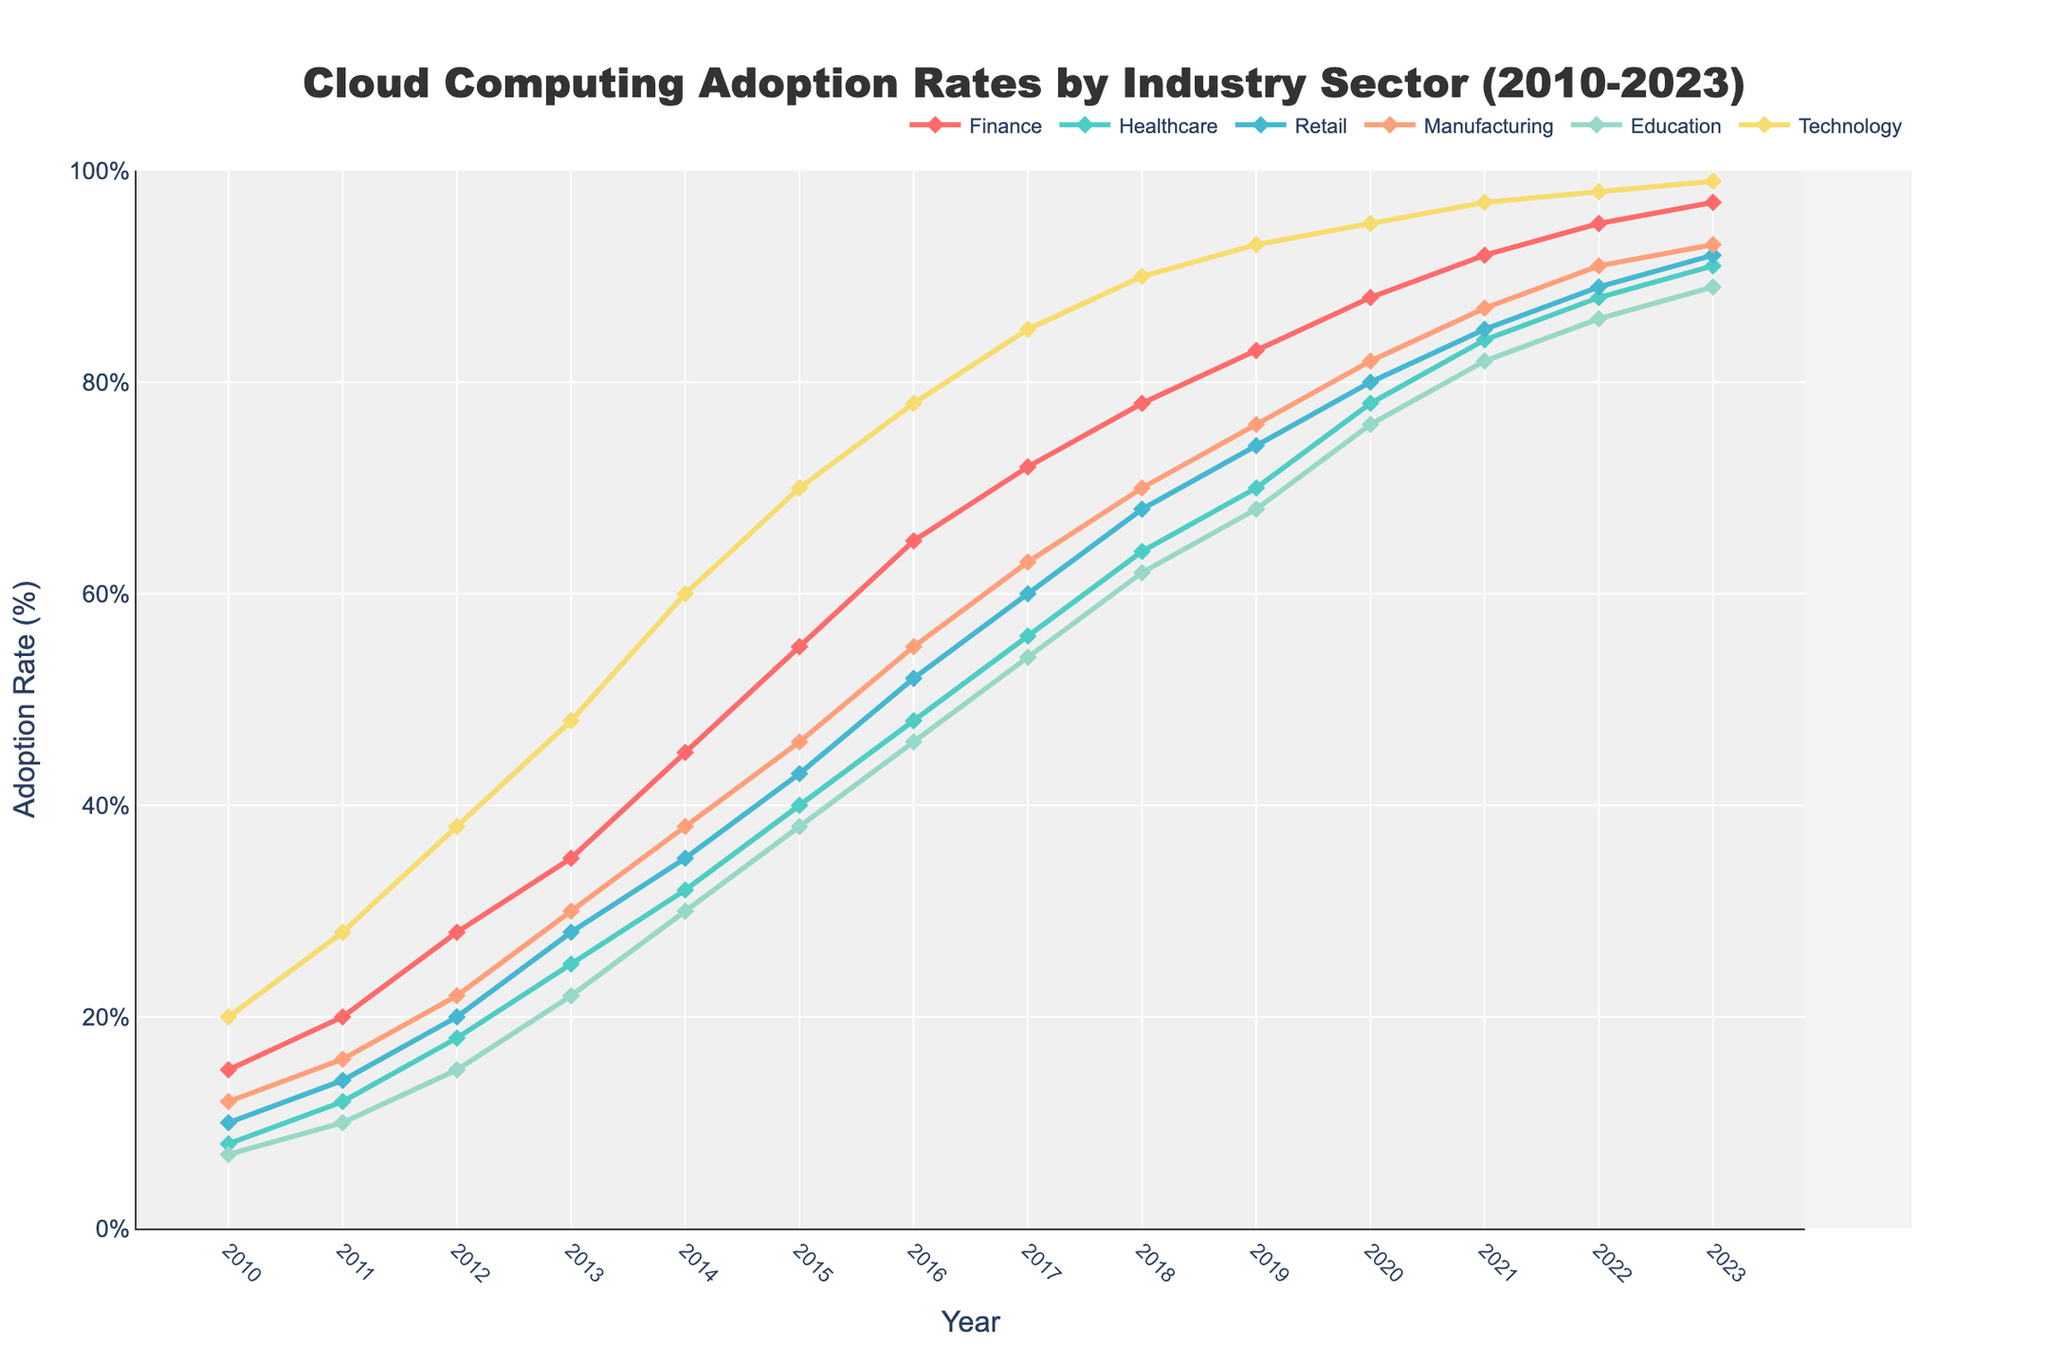What industry sector had the highest adoption rate of cloud computing services in 2023? In 2023, the industry sector with the highest line on the chart represents the highest adoption rate. The Technology sector's line is at the top.
Answer: Technology Between 2015 and 2020, which industry sector showed the most significant increase in adoption rate? Calculate the difference in adoption rates between 2015 and 2020 for each sector. Technology: 95-70=25, Finance: 88-55=33, Healthcare: 78-40=38, Retail: 80-43=37, Manufacturing: 82-46=36, Education: 76-38=38. Healthcare and Education sectors had an increase of 38%.
Answer: Healthcare and Education In what year did the Retail sector's adoption rate first exceed 50%? Look at the point where the Retail sector's line crosses the 50% mark. This happens between 2015 and 2016.
Answer: 2016 Which sector experienced the least growth in adoption rates from 2010 to 2023? Examine the change in adoption rates over the years for each sector. The difference for each sector is: Technology: 99-20=79, Finance: 97-15=82, Healthcare: 91-8=83, Retail: 92-10=82, Manufacturing: 93-12=81, Education: 89-7=82. Technology sector experienced the least growth: 79.
Answer: Technology How did the adoption rate for the Education sector in 2020 compare to that of the Manufacturing sector in 2013? In 2020, the Education sector had a 76% adoption rate. In 2013, the Manufacturing sector had a 30% adoption rate. So, Education's rate in 2020 is higher.
Answer: Education is higher By how much did the Finance sector increase its adoption rate from 2012 to 2014? The difference is calculated as 45 (in 2014) minus 28 (in 2012), which equals 17.
Answer: 17 Which two sectors had adoption rates closest to each other in 2011? Compare the adoption rates for all sectors in 2011 to find the smallest difference. In 2011, Retail: 14 and Manufacturing: 16 have the smallest difference of 2.
Answer: Retail and Manufacturing What is the average adoption rate of the Technology sector over the entire period? Summing up the adoption rates for all years for the Technology sector, we get 20+28+38+48+60+70+78+85+90+93+95+97+98+99 = 999. The period from 2010 to 2023 has 14 years, so 999/14 ≈ 71.36.
Answer: 71.36 Compare the rate of increase in adoption between the Healthcare sector from 2012 to 2013 and the Finance sector from 2022 to 2023. Which one increased more? For Healthcare (2012 to 2013): 25-18=7. For Finance (2022 to 2023): 97-95=2. Thus, Healthcare increased more.
Answer: Healthcare increased more 